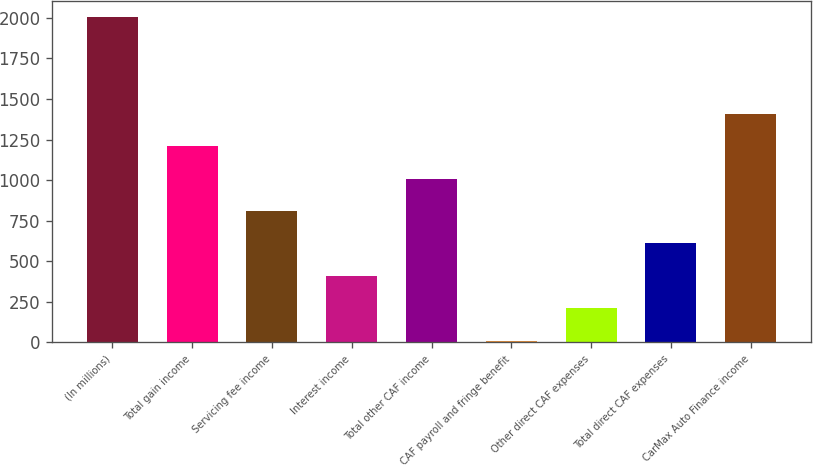<chart> <loc_0><loc_0><loc_500><loc_500><bar_chart><fcel>(In millions)<fcel>Total gain income<fcel>Servicing fee income<fcel>Interest income<fcel>Total other CAF income<fcel>CAF payroll and fringe benefit<fcel>Other direct CAF expenses<fcel>Total direct CAF expenses<fcel>CarMax Auto Finance income<nl><fcel>2006<fcel>1207.72<fcel>808.58<fcel>409.44<fcel>1008.15<fcel>10.3<fcel>209.87<fcel>609.01<fcel>1407.29<nl></chart> 